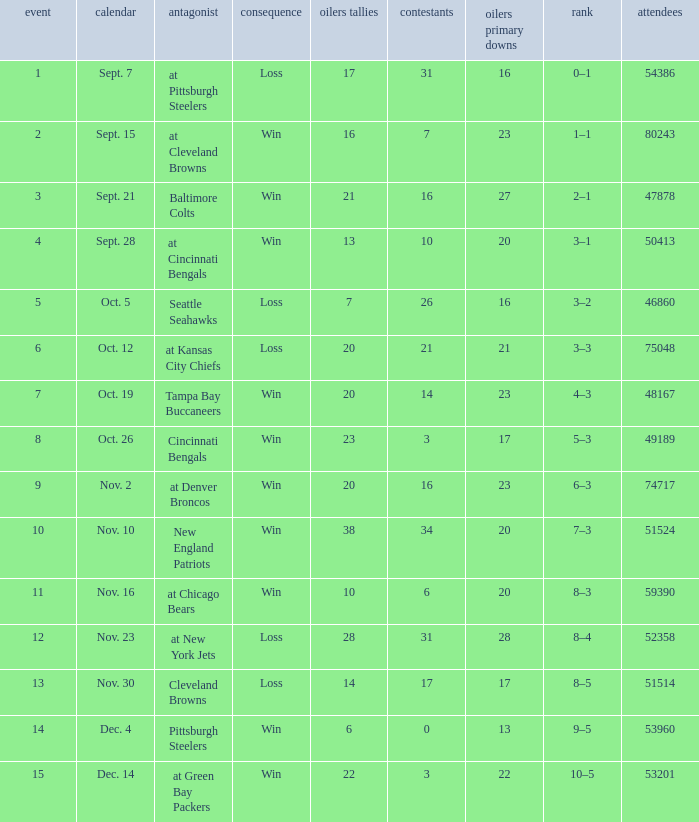What was the total opponents points for the game were the Oilers scored 21? 16.0. Write the full table. {'header': ['event', 'calendar', 'antagonist', 'consequence', 'oilers tallies', 'contestants', 'oilers primary downs', 'rank', 'attendees'], 'rows': [['1', 'Sept. 7', 'at Pittsburgh Steelers', 'Loss', '17', '31', '16', '0–1', '54386'], ['2', 'Sept. 15', 'at Cleveland Browns', 'Win', '16', '7', '23', '1–1', '80243'], ['3', 'Sept. 21', 'Baltimore Colts', 'Win', '21', '16', '27', '2–1', '47878'], ['4', 'Sept. 28', 'at Cincinnati Bengals', 'Win', '13', '10', '20', '3–1', '50413'], ['5', 'Oct. 5', 'Seattle Seahawks', 'Loss', '7', '26', '16', '3–2', '46860'], ['6', 'Oct. 12', 'at Kansas City Chiefs', 'Loss', '20', '21', '21', '3–3', '75048'], ['7', 'Oct. 19', 'Tampa Bay Buccaneers', 'Win', '20', '14', '23', '4–3', '48167'], ['8', 'Oct. 26', 'Cincinnati Bengals', 'Win', '23', '3', '17', '5–3', '49189'], ['9', 'Nov. 2', 'at Denver Broncos', 'Win', '20', '16', '23', '6–3', '74717'], ['10', 'Nov. 10', 'New England Patriots', 'Win', '38', '34', '20', '7–3', '51524'], ['11', 'Nov. 16', 'at Chicago Bears', 'Win', '10', '6', '20', '8–3', '59390'], ['12', 'Nov. 23', 'at New York Jets', 'Loss', '28', '31', '28', '8–4', '52358'], ['13', 'Nov. 30', 'Cleveland Browns', 'Loss', '14', '17', '17', '8–5', '51514'], ['14', 'Dec. 4', 'Pittsburgh Steelers', 'Win', '6', '0', '13', '9–5', '53960'], ['15', 'Dec. 14', 'at Green Bay Packers', 'Win', '22', '3', '22', '10–5', '53201']]} 